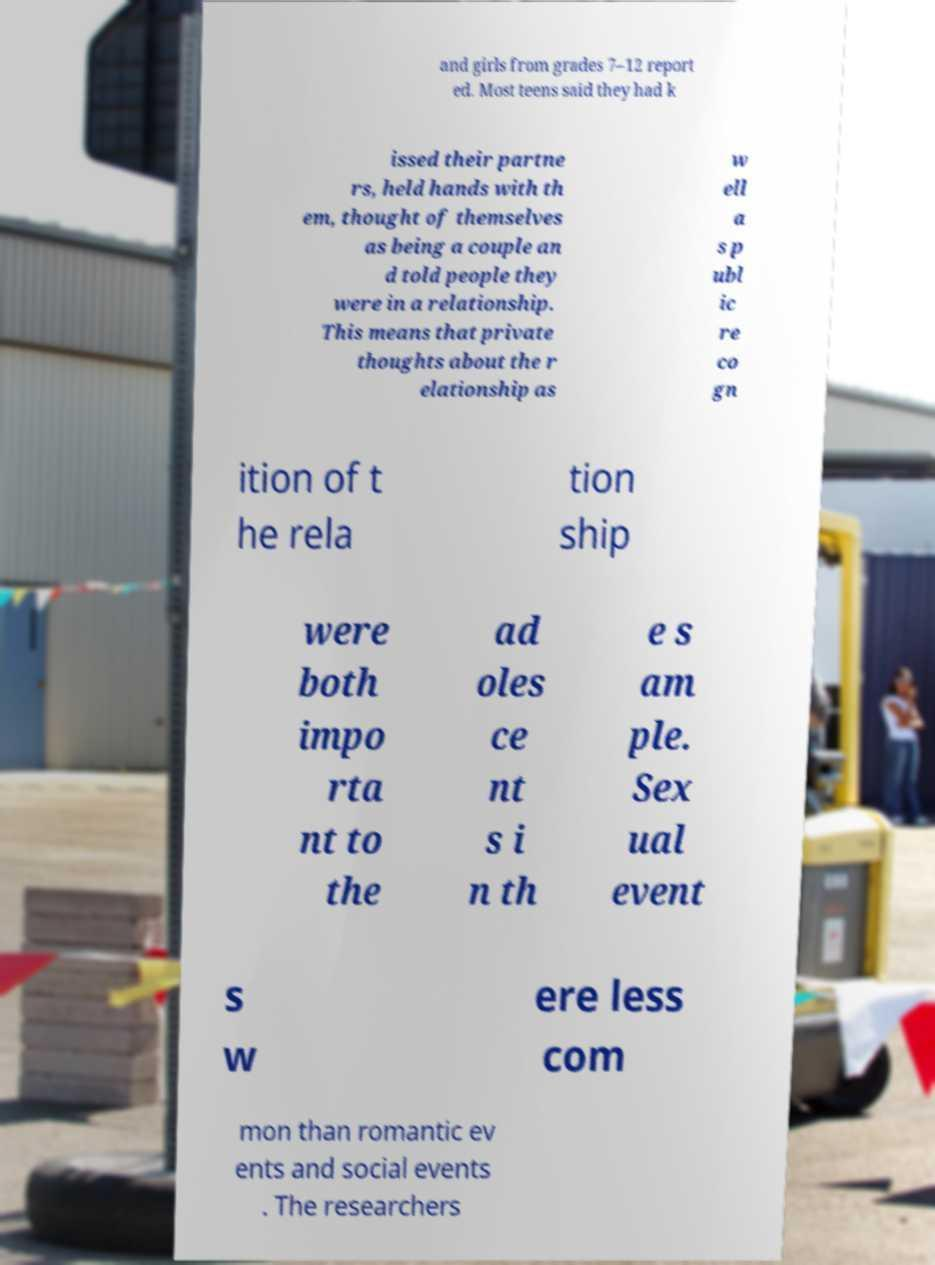Please read and relay the text visible in this image. What does it say? and girls from grades 7–12 report ed. Most teens said they had k issed their partne rs, held hands with th em, thought of themselves as being a couple an d told people they were in a relationship. This means that private thoughts about the r elationship as w ell a s p ubl ic re co gn ition of t he rela tion ship were both impo rta nt to the ad oles ce nt s i n th e s am ple. Sex ual event s w ere less com mon than romantic ev ents and social events . The researchers 